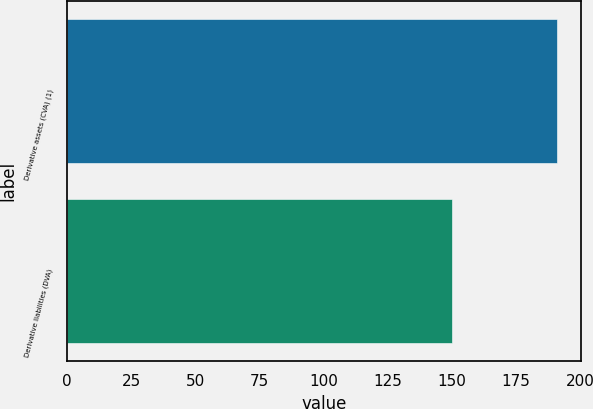<chart> <loc_0><loc_0><loc_500><loc_500><bar_chart><fcel>Derivative assets (CVA) (1)<fcel>Derivative liabilities (DVA)<nl><fcel>191<fcel>150<nl></chart> 